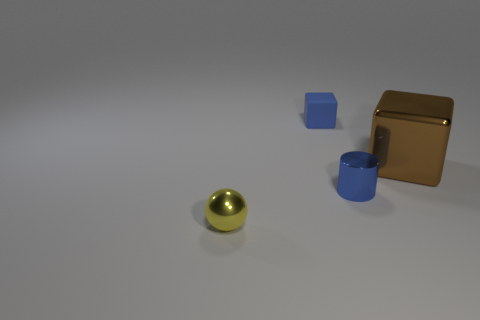Add 2 tiny cylinders. How many objects exist? 6 Subtract all spheres. How many objects are left? 3 Add 2 blue metal objects. How many blue metal objects are left? 3 Add 1 tiny brown shiny objects. How many tiny brown shiny objects exist? 1 Subtract 1 brown blocks. How many objects are left? 3 Subtract all gray shiny balls. Subtract all metallic spheres. How many objects are left? 3 